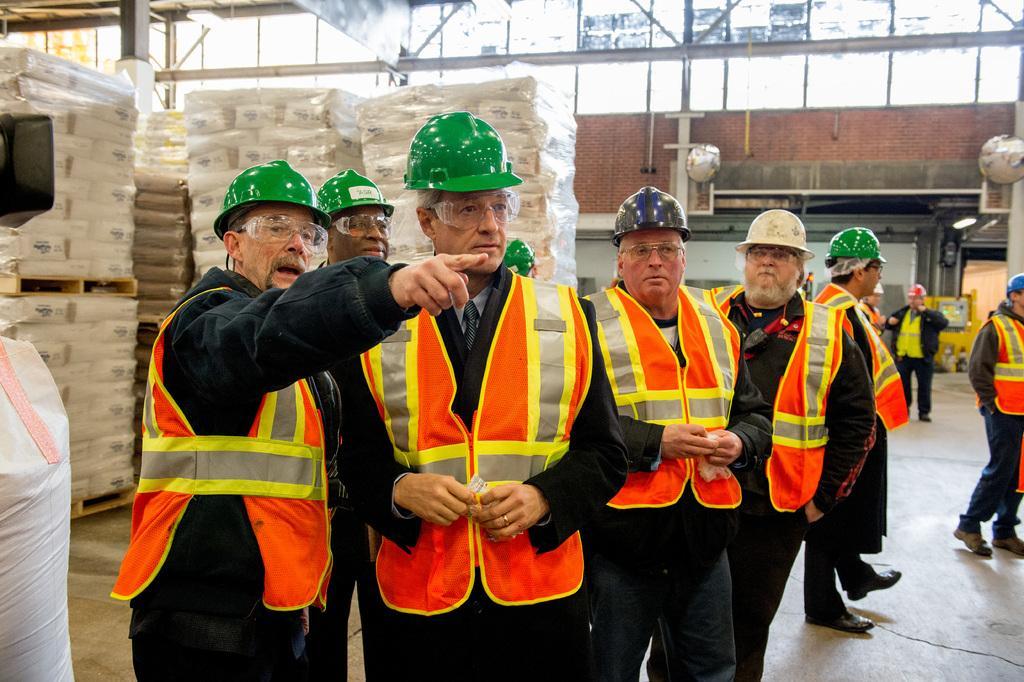Please provide a concise description of this image. This image is taken indoors. In the background there is a wall. There are a few pipelines. A vehicle is parked on the ground. There are a few windows. There are many objects on the trolleys. In the middle of the image a few men are standing on the floor. On the right side of the image a man is walking and two men are standing. On the left side of the image there is an object. 